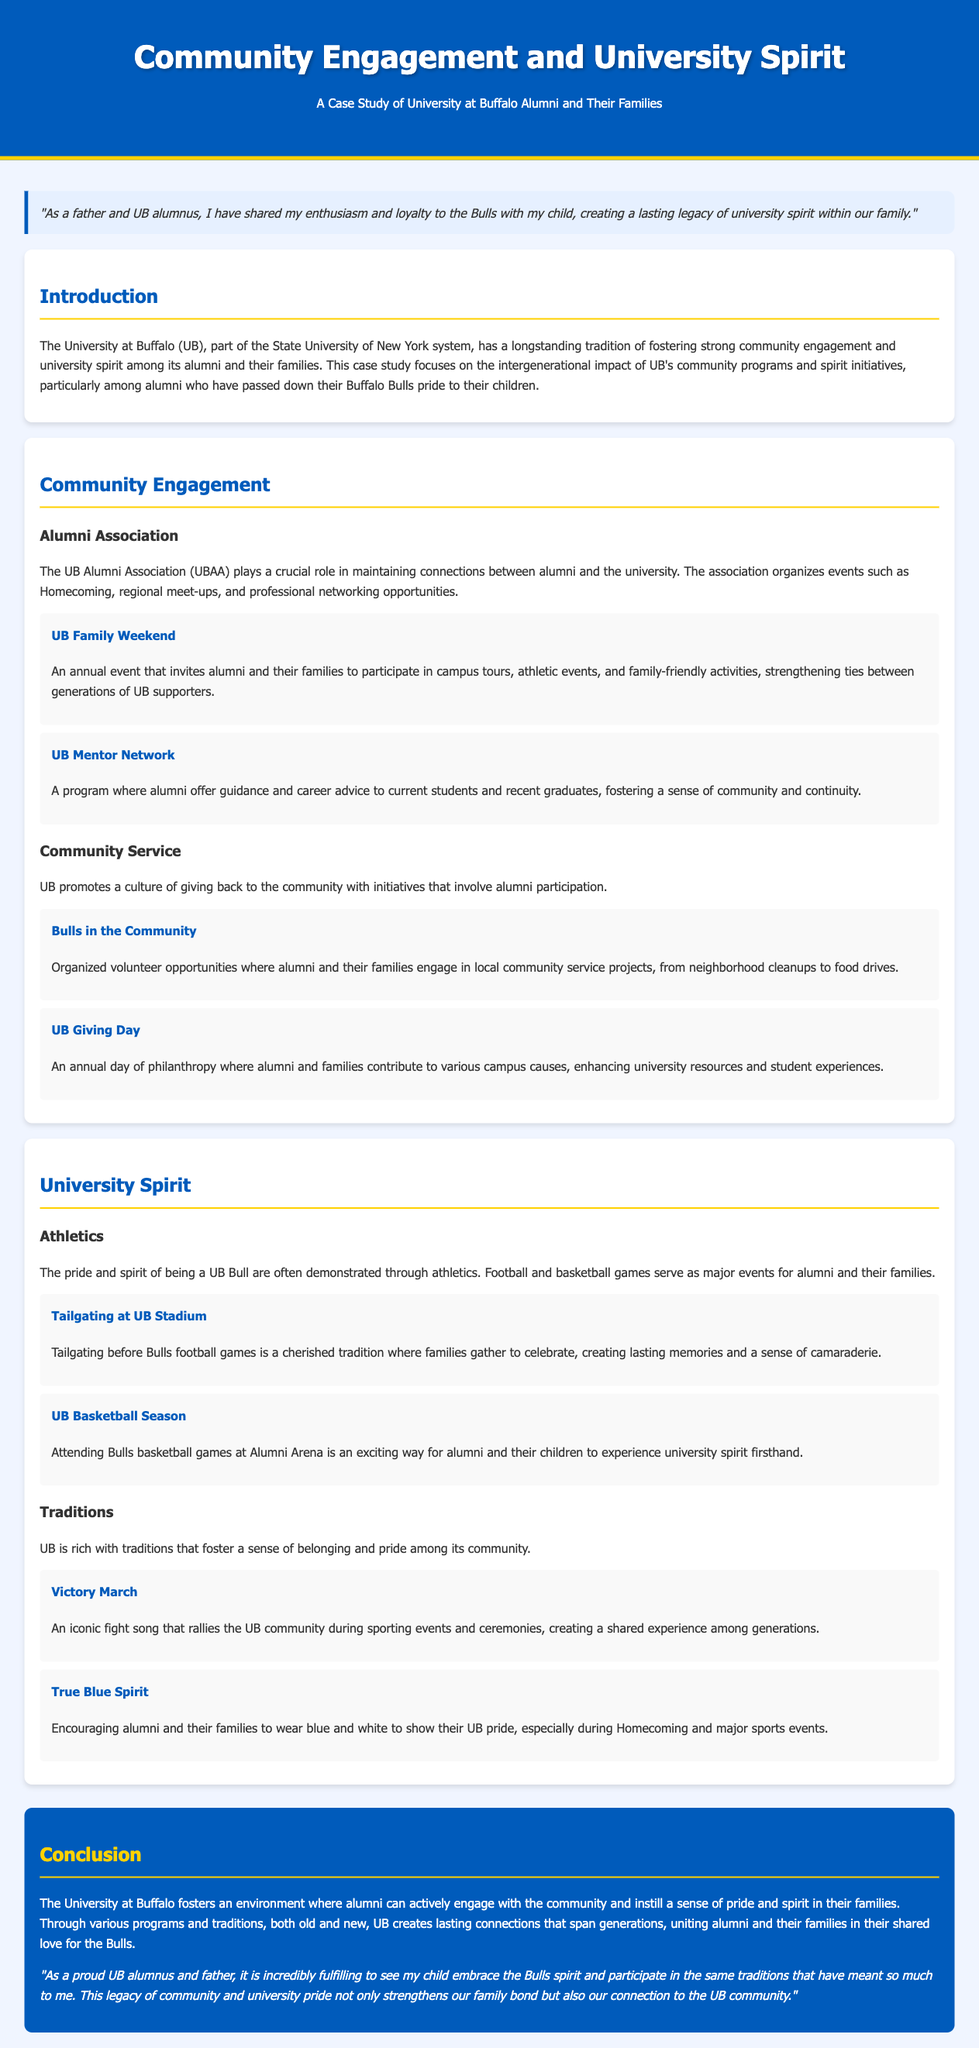What is the name of the annual event that invites alumni and their families? The document mentions "UB Family Weekend" as the annual event inviting alumni and their families to participate in various activities.
Answer: UB Family Weekend What is the role of the UB Alumni Association? The UB Alumni Association maintains connections between alumni and the university by organizing events such as Homecoming and regional meet-ups.
Answer: Maintaining connections How do alumni contribute on UB Giving Day? The document states that UB Giving Day is a day of philanthropy where alumni contribute to various campus causes to enhance university resources.
Answer: Philanthropy What major sports events are mentioned for showcasing university spirit? The document highlights that football and basketball games are major events for alumni and their families to demonstrate their pride.
Answer: Football and basketball games What tradition encourages alumni to wear blue and white? The document discusses "True Blue Spirit" as the tradition that encourages alumni and their families to wear UB colors during special events.
Answer: True Blue Spirit What is the community service initiative involving alumni? The program "Bulls in the Community" organizes volunteer opportunities that involve alumni and their families in local service projects.
Answer: Bulls in the Community Which location hosts Bulls basketball games? The document mentions Alumni Arena as the location for attending Bulls basketball games.
Answer: Alumni Arena What impact does the study focus on regarding UB's community programs? The study focuses on the intergenerational impact of UB's community programs and spirit initiatives among alumni and their children.
Answer: Intergenerational impact What emotion does the persona feel about sharing UB spirit with their child? The persona expresses fulfillment about their child embracing the Bulls spirit and participating in significant traditions.
Answer: Fulfillment 